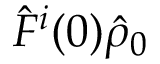Convert formula to latex. <formula><loc_0><loc_0><loc_500><loc_500>\hat { F } ^ { i } ( 0 ) \hat { \rho } _ { 0 }</formula> 